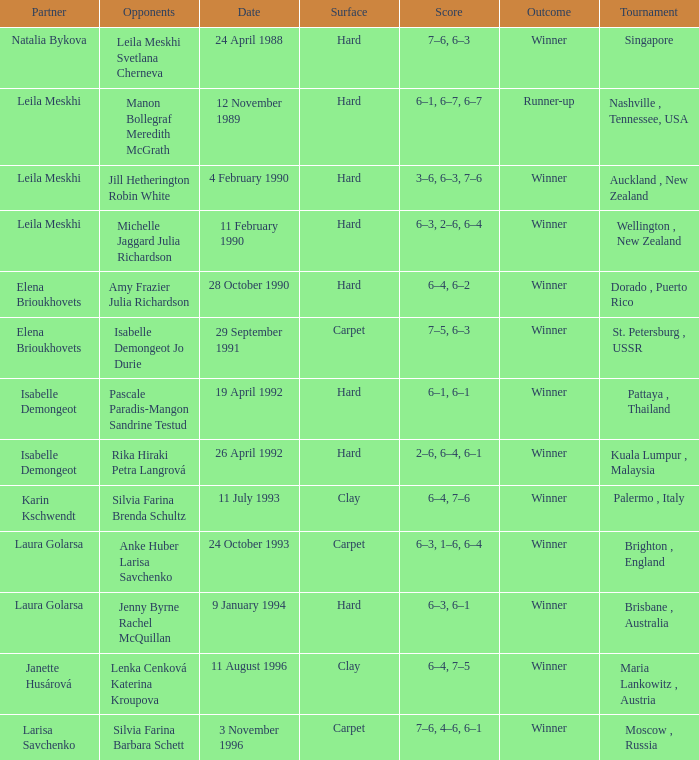On what Date was the Score 6–4, 6–2? 28 October 1990. 